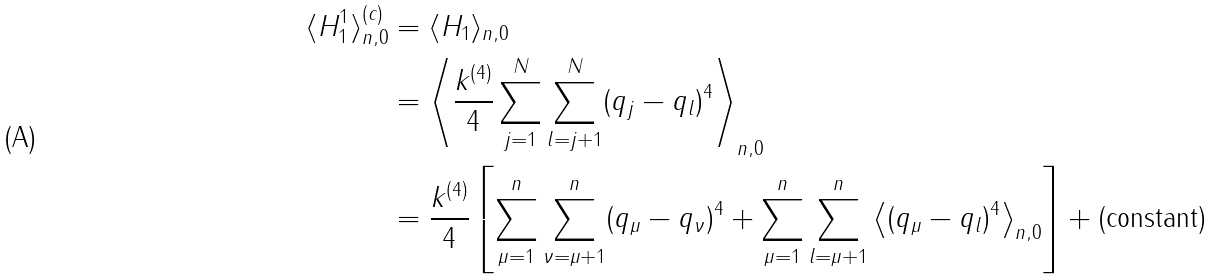Convert formula to latex. <formula><loc_0><loc_0><loc_500><loc_500>\langle H _ { 1 } ^ { 1 } \rangle _ { n , 0 } ^ { ( c ) } & = \langle H _ { 1 } \rangle _ { n , 0 } \\ & = \left \langle \frac { k ^ { ( 4 ) } } { 4 } \sum _ { j = 1 } ^ { N } \sum _ { l = j + 1 } ^ { N } ( q _ { j } - q _ { l } ) ^ { 4 } \right \rangle _ { n , 0 } \\ & = \frac { k ^ { ( 4 ) } } { 4 } \left [ \sum _ { \mu = 1 } ^ { n } \sum _ { \nu = \mu + 1 } ^ { n } ( q _ { \mu } - q _ { \nu } ) ^ { 4 } + \sum _ { \mu = 1 } ^ { n } \sum _ { l = \mu + 1 } ^ { n } \left \langle ( q _ { \mu } - q _ { l } ) ^ { 4 } \right \rangle _ { n , 0 } \right ] + \text {(constant)}</formula> 